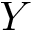<formula> <loc_0><loc_0><loc_500><loc_500>Y</formula> 